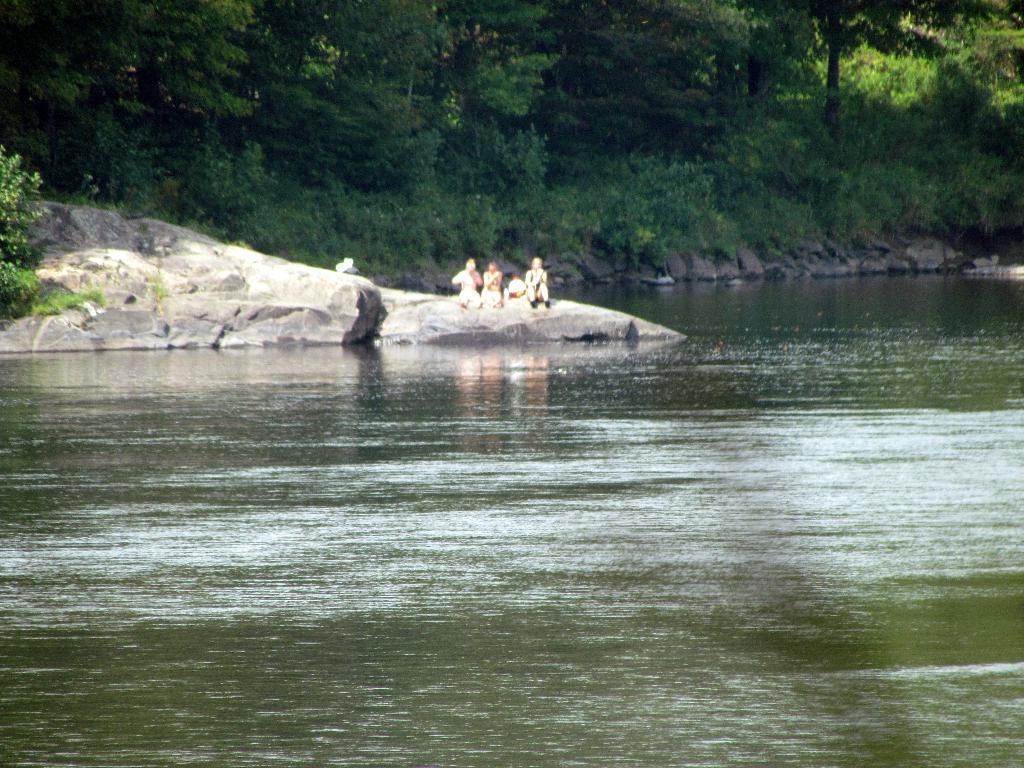In one or two sentences, can you explain what this image depicts? In this picture we can see the water, three people sitting on rocks and some objects and in the background we can see trees. 